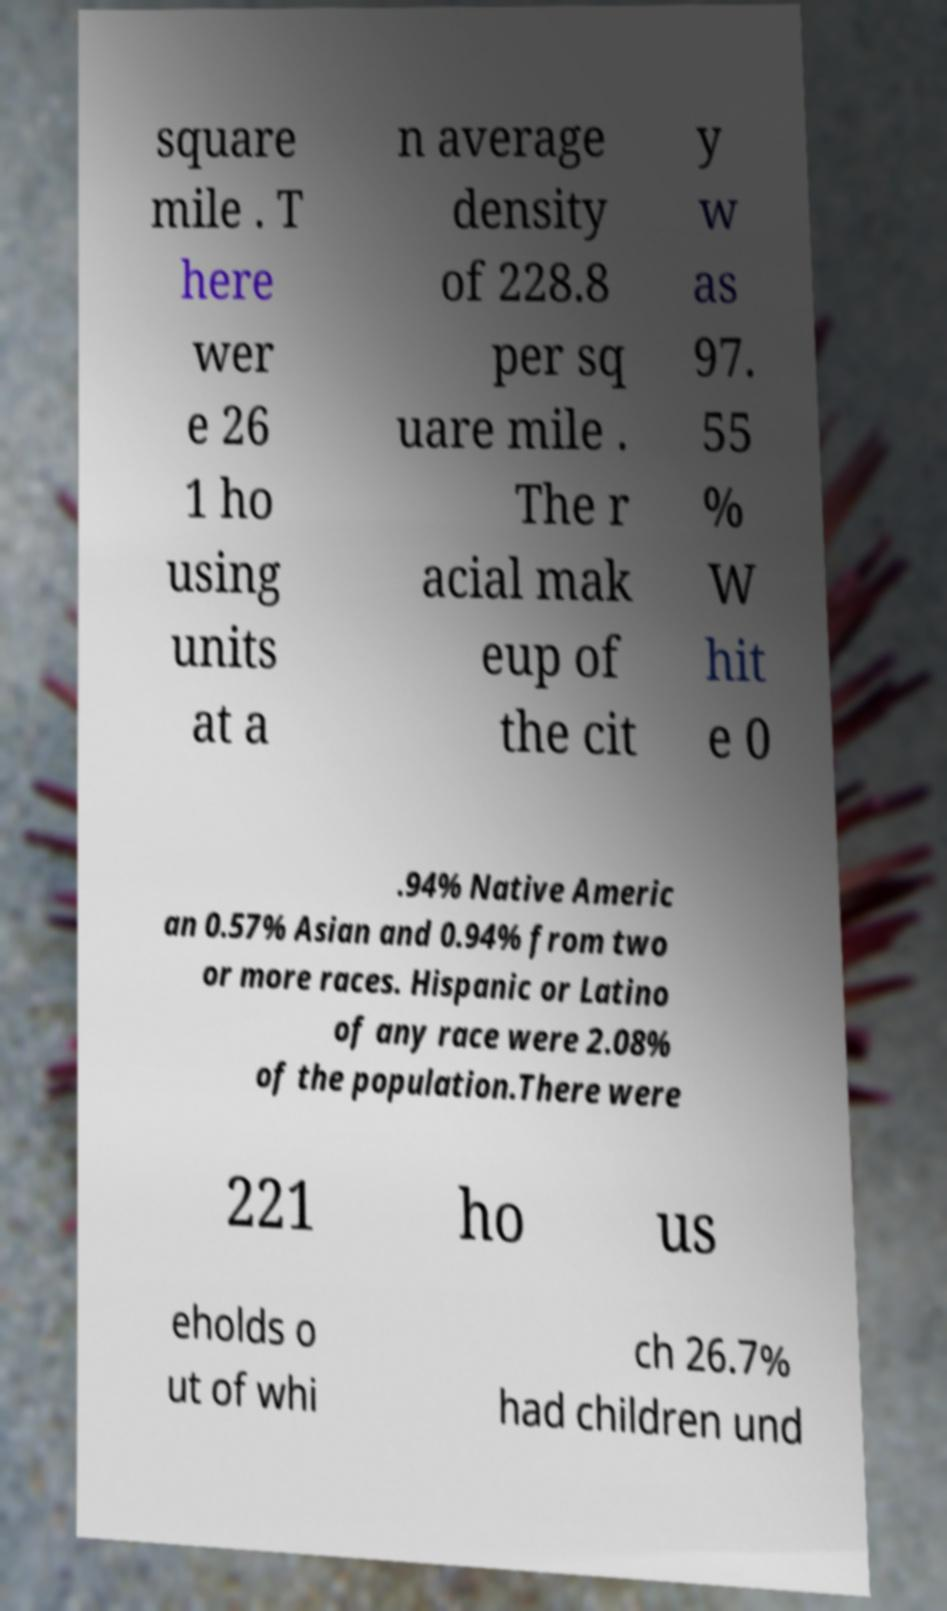Could you assist in decoding the text presented in this image and type it out clearly? square mile . T here wer e 26 1 ho using units at a n average density of 228.8 per sq uare mile . The r acial mak eup of the cit y w as 97. 55 % W hit e 0 .94% Native Americ an 0.57% Asian and 0.94% from two or more races. Hispanic or Latino of any race were 2.08% of the population.There were 221 ho us eholds o ut of whi ch 26.7% had children und 